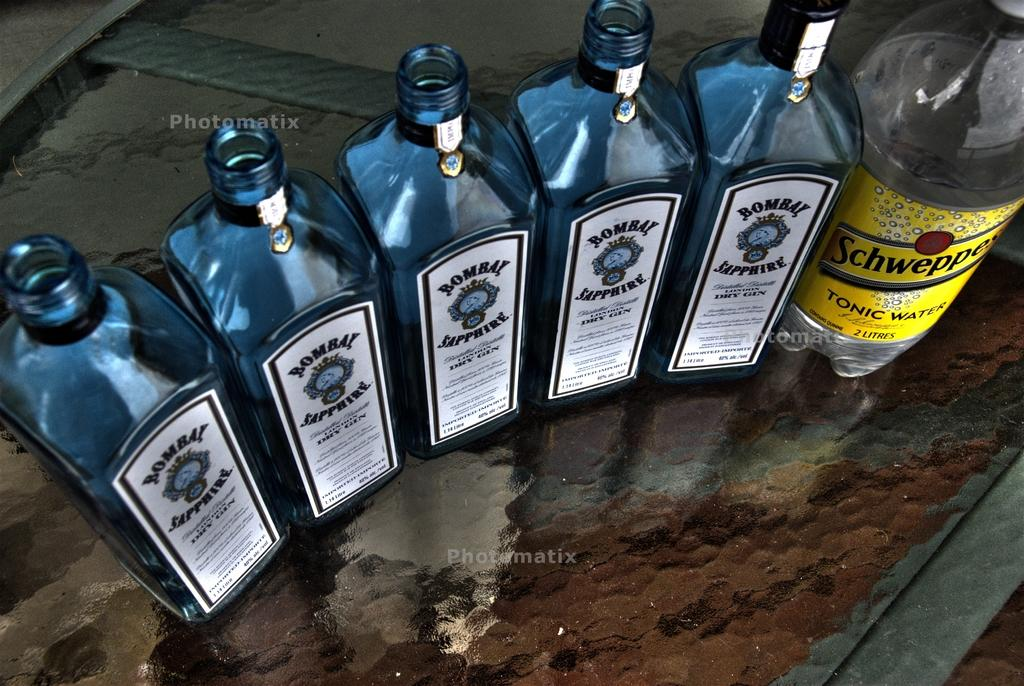Provide a one-sentence caption for the provided image. A bottle of Schweepes Tonic water is next to five bottle of Bombay Sapphire. 